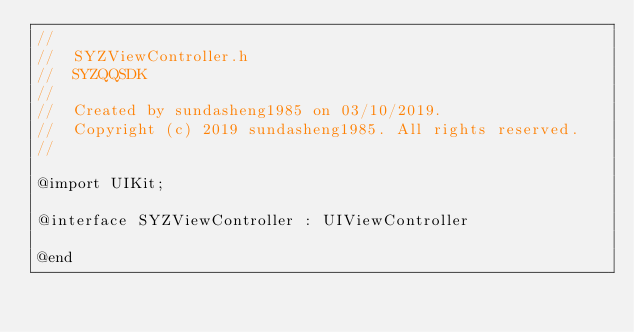Convert code to text. <code><loc_0><loc_0><loc_500><loc_500><_C_>//
//  SYZViewController.h
//  SYZQQSDK
//
//  Created by sundasheng1985 on 03/10/2019.
//  Copyright (c) 2019 sundasheng1985. All rights reserved.
//

@import UIKit;

@interface SYZViewController : UIViewController

@end
</code> 